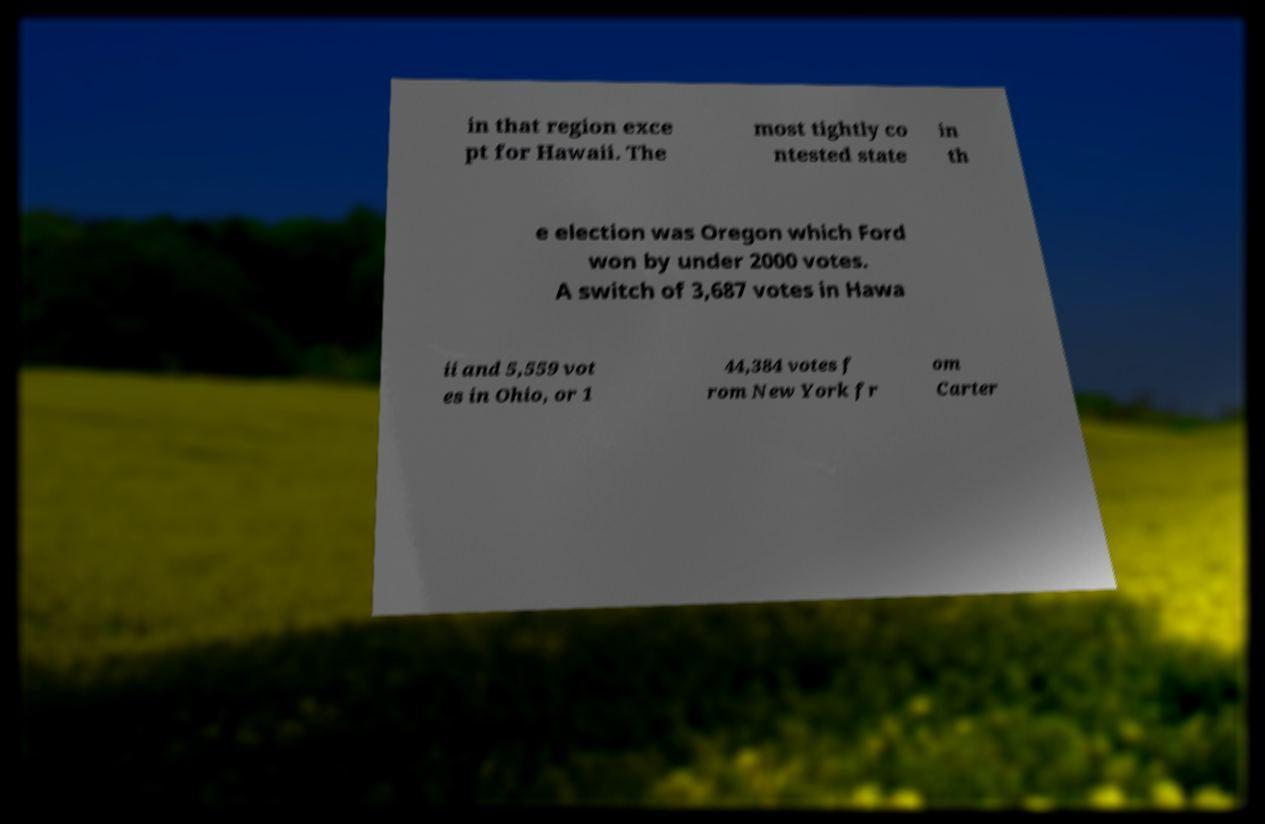Could you assist in decoding the text presented in this image and type it out clearly? in that region exce pt for Hawaii. The most tightly co ntested state in th e election was Oregon which Ford won by under 2000 votes. A switch of 3,687 votes in Hawa ii and 5,559 vot es in Ohio, or 1 44,384 votes f rom New York fr om Carter 